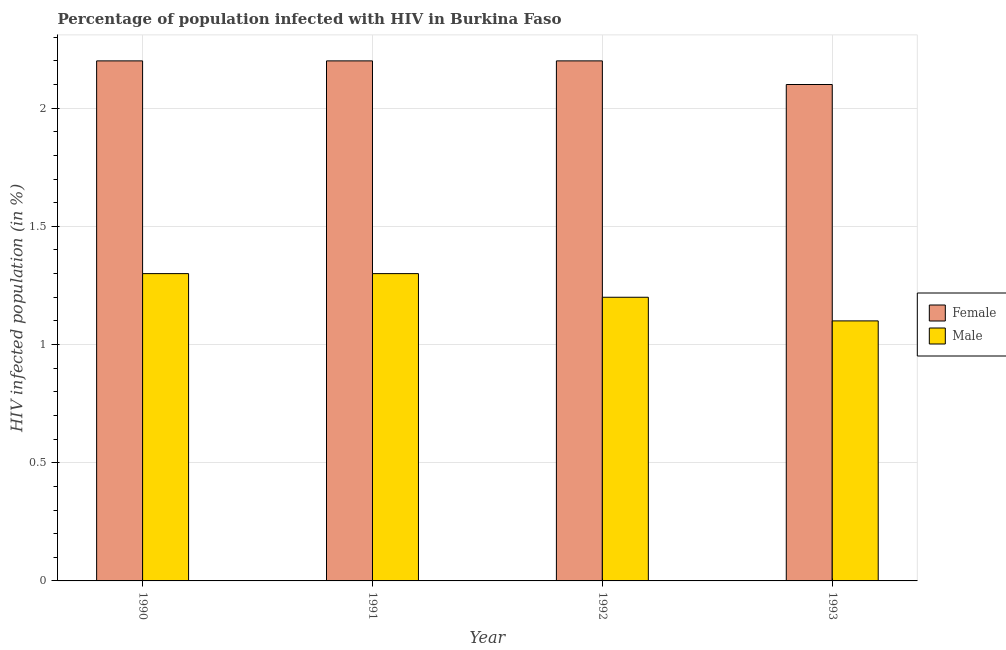How many different coloured bars are there?
Your answer should be very brief. 2. Are the number of bars per tick equal to the number of legend labels?
Your answer should be very brief. Yes. What is the percentage of females who are infected with hiv in 1991?
Make the answer very short. 2.2. Across all years, what is the maximum percentage of males who are infected with hiv?
Provide a short and direct response. 1.3. In which year was the percentage of females who are infected with hiv minimum?
Keep it short and to the point. 1993. What is the difference between the percentage of females who are infected with hiv in 1992 and that in 1993?
Ensure brevity in your answer.  0.1. What is the difference between the percentage of females who are infected with hiv in 1990 and the percentage of males who are infected with hiv in 1993?
Your answer should be compact. 0.1. What is the average percentage of females who are infected with hiv per year?
Provide a succinct answer. 2.18. What is the ratio of the percentage of males who are infected with hiv in 1990 to that in 1993?
Give a very brief answer. 1.18. Is the percentage of males who are infected with hiv in 1991 less than that in 1992?
Give a very brief answer. No. Is the difference between the percentage of males who are infected with hiv in 1992 and 1993 greater than the difference between the percentage of females who are infected with hiv in 1992 and 1993?
Keep it short and to the point. No. What is the difference between the highest and the second highest percentage of males who are infected with hiv?
Provide a short and direct response. 0. What is the difference between the highest and the lowest percentage of males who are infected with hiv?
Offer a terse response. 0.2. In how many years, is the percentage of males who are infected with hiv greater than the average percentage of males who are infected with hiv taken over all years?
Your answer should be very brief. 2. What does the 2nd bar from the right in 1990 represents?
Provide a short and direct response. Female. How many years are there in the graph?
Keep it short and to the point. 4. What is the difference between two consecutive major ticks on the Y-axis?
Your answer should be compact. 0.5. Where does the legend appear in the graph?
Give a very brief answer. Center right. How many legend labels are there?
Offer a very short reply. 2. How are the legend labels stacked?
Keep it short and to the point. Vertical. What is the title of the graph?
Give a very brief answer. Percentage of population infected with HIV in Burkina Faso. What is the label or title of the Y-axis?
Your answer should be compact. HIV infected population (in %). What is the HIV infected population (in %) of Female in 1990?
Your answer should be very brief. 2.2. What is the HIV infected population (in %) in Female in 1993?
Offer a very short reply. 2.1. Across all years, what is the maximum HIV infected population (in %) of Male?
Your response must be concise. 1.3. Across all years, what is the minimum HIV infected population (in %) in Female?
Your answer should be very brief. 2.1. Across all years, what is the minimum HIV infected population (in %) of Male?
Your answer should be compact. 1.1. What is the total HIV infected population (in %) in Female in the graph?
Keep it short and to the point. 8.7. What is the difference between the HIV infected population (in %) of Male in 1990 and that in 1991?
Provide a succinct answer. 0. What is the difference between the HIV infected population (in %) of Male in 1990 and that in 1992?
Provide a short and direct response. 0.1. What is the difference between the HIV infected population (in %) of Female in 1990 and the HIV infected population (in %) of Male in 1991?
Your response must be concise. 0.9. What is the difference between the HIV infected population (in %) in Female in 1990 and the HIV infected population (in %) in Male in 1993?
Keep it short and to the point. 1.1. What is the difference between the HIV infected population (in %) of Female in 1991 and the HIV infected population (in %) of Male in 1992?
Ensure brevity in your answer.  1. What is the difference between the HIV infected population (in %) in Female in 1992 and the HIV infected population (in %) in Male in 1993?
Give a very brief answer. 1.1. What is the average HIV infected population (in %) of Female per year?
Provide a succinct answer. 2.17. What is the average HIV infected population (in %) of Male per year?
Ensure brevity in your answer.  1.23. In the year 1991, what is the difference between the HIV infected population (in %) in Female and HIV infected population (in %) in Male?
Make the answer very short. 0.9. In the year 1992, what is the difference between the HIV infected population (in %) of Female and HIV infected population (in %) of Male?
Offer a terse response. 1. What is the ratio of the HIV infected population (in %) in Female in 1990 to that in 1991?
Offer a very short reply. 1. What is the ratio of the HIV infected population (in %) in Male in 1990 to that in 1991?
Offer a very short reply. 1. What is the ratio of the HIV infected population (in %) of Male in 1990 to that in 1992?
Your answer should be compact. 1.08. What is the ratio of the HIV infected population (in %) of Female in 1990 to that in 1993?
Keep it short and to the point. 1.05. What is the ratio of the HIV infected population (in %) in Male in 1990 to that in 1993?
Provide a short and direct response. 1.18. What is the ratio of the HIV infected population (in %) in Female in 1991 to that in 1993?
Give a very brief answer. 1.05. What is the ratio of the HIV infected population (in %) of Male in 1991 to that in 1993?
Provide a succinct answer. 1.18. What is the ratio of the HIV infected population (in %) of Female in 1992 to that in 1993?
Your answer should be compact. 1.05. What is the difference between the highest and the lowest HIV infected population (in %) in Female?
Keep it short and to the point. 0.1. What is the difference between the highest and the lowest HIV infected population (in %) in Male?
Offer a very short reply. 0.2. 